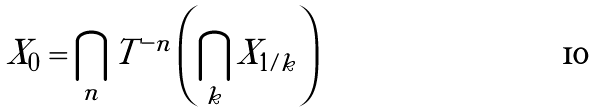<formula> <loc_0><loc_0><loc_500><loc_500>X _ { 0 } = \bigcap _ { n } T ^ { - n } \left ( \bigcap _ { k } X _ { 1 / k } \right )</formula> 